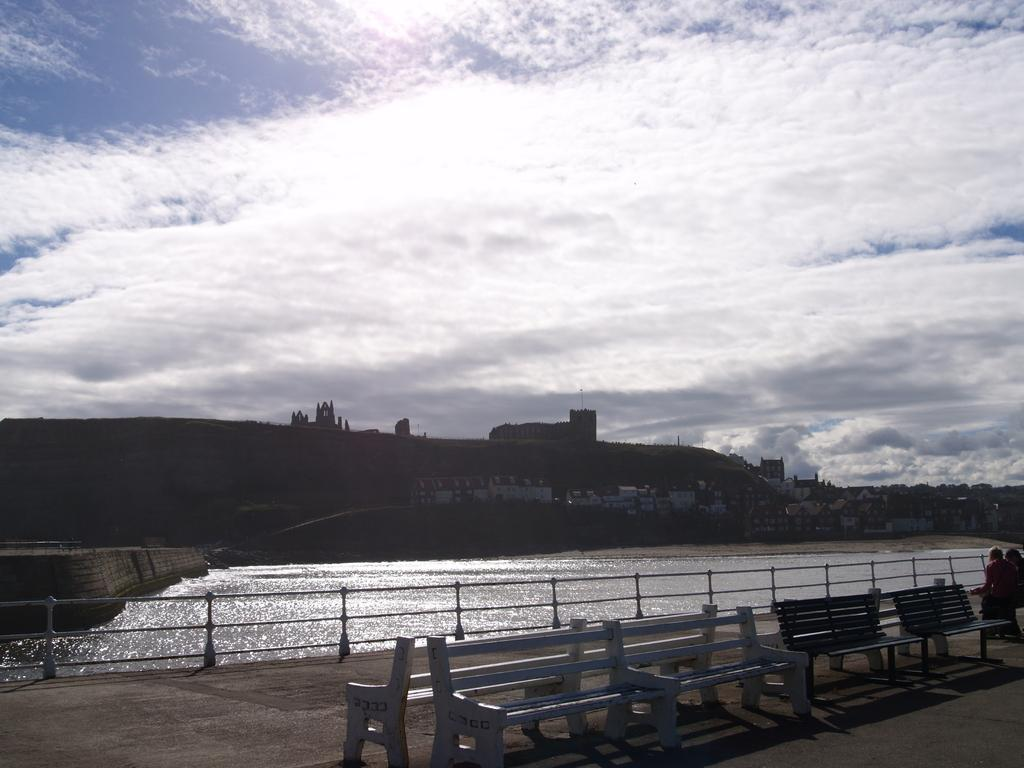What type of seating is present at the bottom of the image? There are sitting benches at the bottom of the image. What is located in the middle of the image? There is water in the middle of the image. What is visible at the top of the image? The sky is visible at the top of the image. How would you describe the sky in the image? The sky appears to be cloudy. How many crows are perched on the sitting benches in the image? There are no crows present in the image; it only features sitting benches, water, and a cloudy sky. What type of plants can be seen growing in the water in the image? There are no plants visible in the water in the image; it only features water and a cloudy sky. 